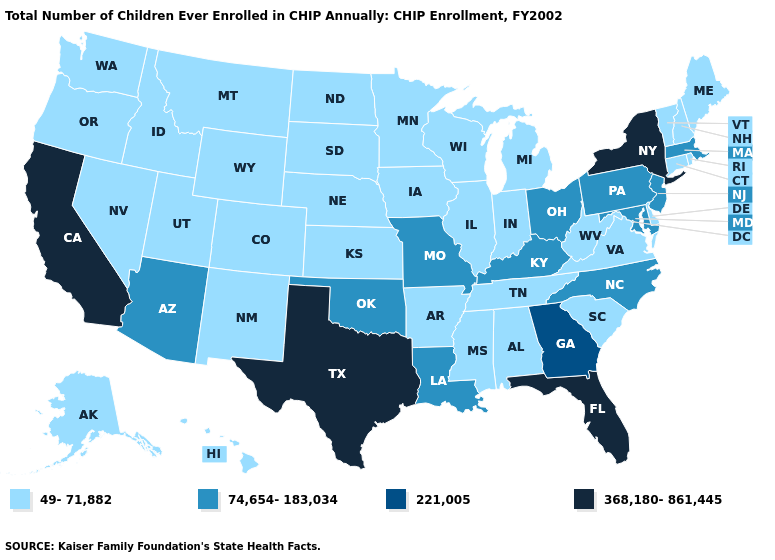Name the states that have a value in the range 221,005?
Keep it brief. Georgia. Which states have the highest value in the USA?
Short answer required. California, Florida, New York, Texas. Among the states that border Missouri , which have the highest value?
Quick response, please. Kentucky, Oklahoma. Among the states that border Oklahoma , which have the lowest value?
Quick response, please. Arkansas, Colorado, Kansas, New Mexico. What is the highest value in the USA?
Short answer required. 368,180-861,445. What is the lowest value in the USA?
Give a very brief answer. 49-71,882. Name the states that have a value in the range 221,005?
Short answer required. Georgia. What is the highest value in states that border South Carolina?
Quick response, please. 221,005. Which states have the lowest value in the West?
Concise answer only. Alaska, Colorado, Hawaii, Idaho, Montana, Nevada, New Mexico, Oregon, Utah, Washington, Wyoming. What is the highest value in states that border Florida?
Concise answer only. 221,005. What is the value of Minnesota?
Short answer required. 49-71,882. How many symbols are there in the legend?
Keep it brief. 4. Does New Jersey have the lowest value in the Northeast?
Quick response, please. No. Does Kentucky have the highest value in the USA?
Quick response, please. No. Name the states that have a value in the range 221,005?
Concise answer only. Georgia. 